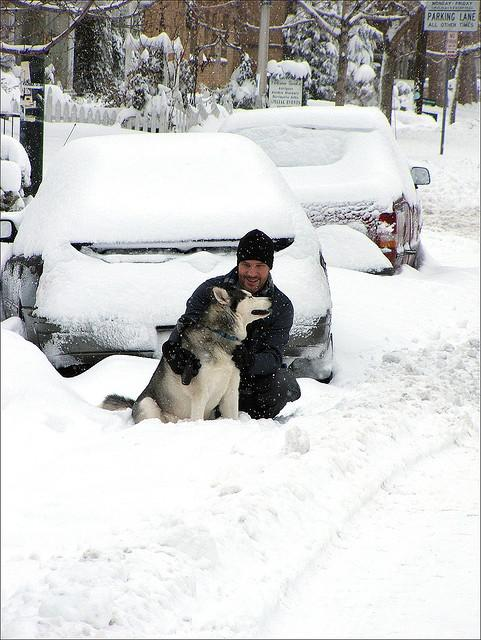This animal is the same species as what character on Game of Thrones?

Choices:
A) hot pie
B) ghost
C) hound
D) mountain ghost 